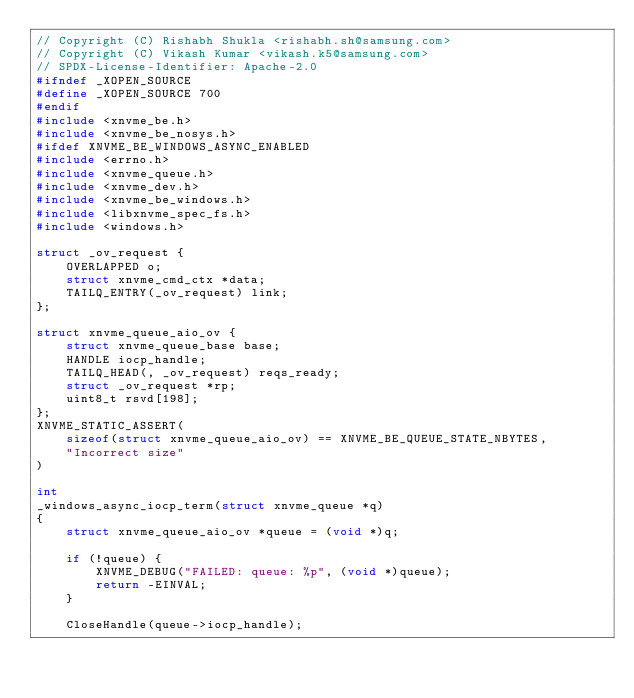<code> <loc_0><loc_0><loc_500><loc_500><_C_>// Copyright (C) Rishabh Shukla <rishabh.sh@samsung.com>
// Copyright (C) Vikash Kumar <vikash.k5@samsung.com>
// SPDX-License-Identifier: Apache-2.0
#ifndef _XOPEN_SOURCE
#define _XOPEN_SOURCE 700
#endif
#include <xnvme_be.h>
#include <xnvme_be_nosys.h>
#ifdef XNVME_BE_WINDOWS_ASYNC_ENABLED
#include <errno.h>
#include <xnvme_queue.h>
#include <xnvme_dev.h>
#include <xnvme_be_windows.h>
#include <libxnvme_spec_fs.h>
#include <windows.h>

struct _ov_request {
	OVERLAPPED o;
	struct xnvme_cmd_ctx *data;
	TAILQ_ENTRY(_ov_request) link;
};

struct xnvme_queue_aio_ov {
	struct xnvme_queue_base base;
	HANDLE iocp_handle;
	TAILQ_HEAD(, _ov_request) reqs_ready;
	struct _ov_request *rp;
	uint8_t rsvd[198];
};
XNVME_STATIC_ASSERT(
	sizeof(struct xnvme_queue_aio_ov) == XNVME_BE_QUEUE_STATE_NBYTES,
	"Incorrect size"
)

int
_windows_async_iocp_term(struct xnvme_queue *q)
{
	struct xnvme_queue_aio_ov *queue = (void *)q;

	if (!queue) {
		XNVME_DEBUG("FAILED: queue: %p", (void *)queue);
		return -EINVAL;
	}

	CloseHandle(queue->iocp_handle);
</code> 